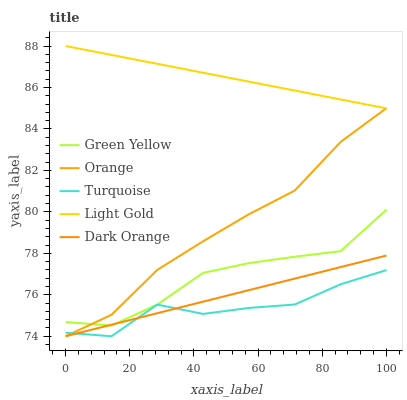Does Dark Orange have the minimum area under the curve?
Answer yes or no. No. Does Dark Orange have the maximum area under the curve?
Answer yes or no. No. Is Turquoise the smoothest?
Answer yes or no. No. Is Dark Orange the roughest?
Answer yes or no. No. Does Green Yellow have the lowest value?
Answer yes or no. No. Does Dark Orange have the highest value?
Answer yes or no. No. Is Turquoise less than Light Gold?
Answer yes or no. Yes. Is Light Gold greater than Dark Orange?
Answer yes or no. Yes. Does Turquoise intersect Light Gold?
Answer yes or no. No. 